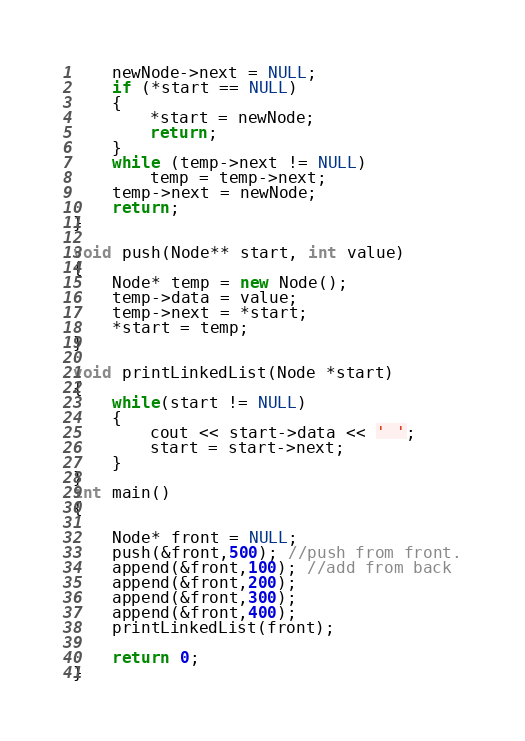Convert code to text. <code><loc_0><loc_0><loc_500><loc_500><_C++_>    newNode->next = NULL;  
    if (*start == NULL)  
    {  
        *start = newNode;  
        return;  
    }  
    while (temp->next != NULL)  
        temp = temp->next; 
    temp->next = newNode;  
    return;  
} 

void push(Node** start, int value)
{
	Node* temp = new Node();
	temp->data = value;
	temp->next = *start;
	*start = temp;
} 

void printLinkedList(Node *start)
{
	while(start != NULL)
	{
		cout << start->data << ' ';
		start = start->next;
	}
}
int main()
{

	Node* front = NULL;
	push(&front,500); //push from front.
	append(&front,100); //add from back
	append(&front,200);
	append(&front,300);
	append(&front,400);
	printLinkedList(front);

	return 0;
}
</code> 